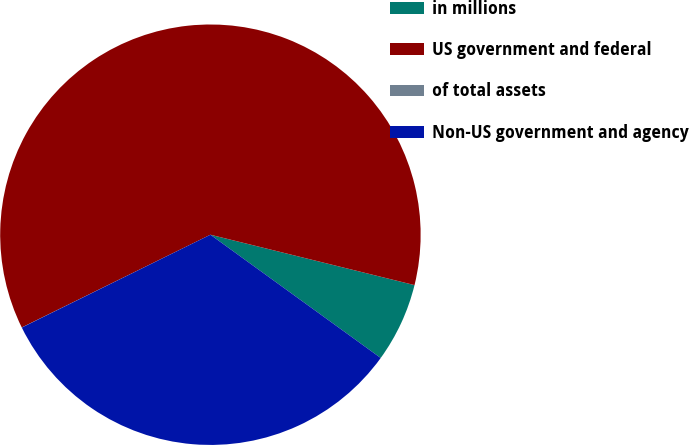Convert chart to OTSL. <chart><loc_0><loc_0><loc_500><loc_500><pie_chart><fcel>in millions<fcel>US government and federal<fcel>of total assets<fcel>Non-US government and agency<nl><fcel>6.12%<fcel>61.13%<fcel>0.01%<fcel>32.75%<nl></chart> 